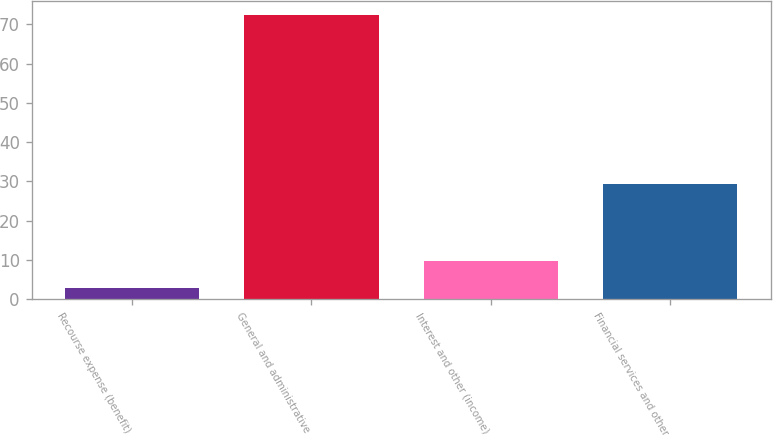Convert chart to OTSL. <chart><loc_0><loc_0><loc_500><loc_500><bar_chart><fcel>Recourse expense (benefit)<fcel>General and administrative<fcel>Interest and other (income)<fcel>Financial services and other<nl><fcel>2.8<fcel>72.3<fcel>9.75<fcel>29.3<nl></chart> 